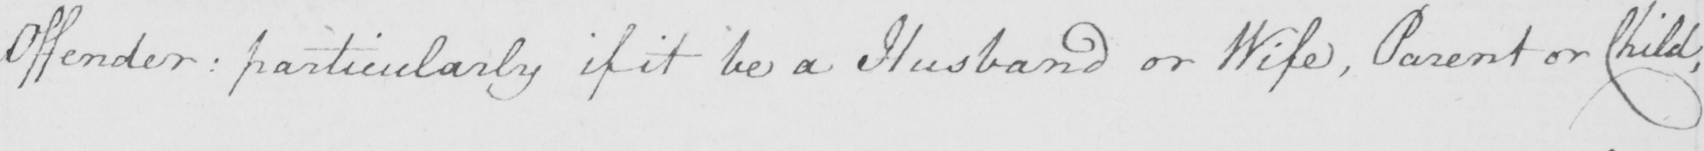Please provide the text content of this handwritten line. Offender :  particularly if it be a Husband or Wife , Parent or Child , 